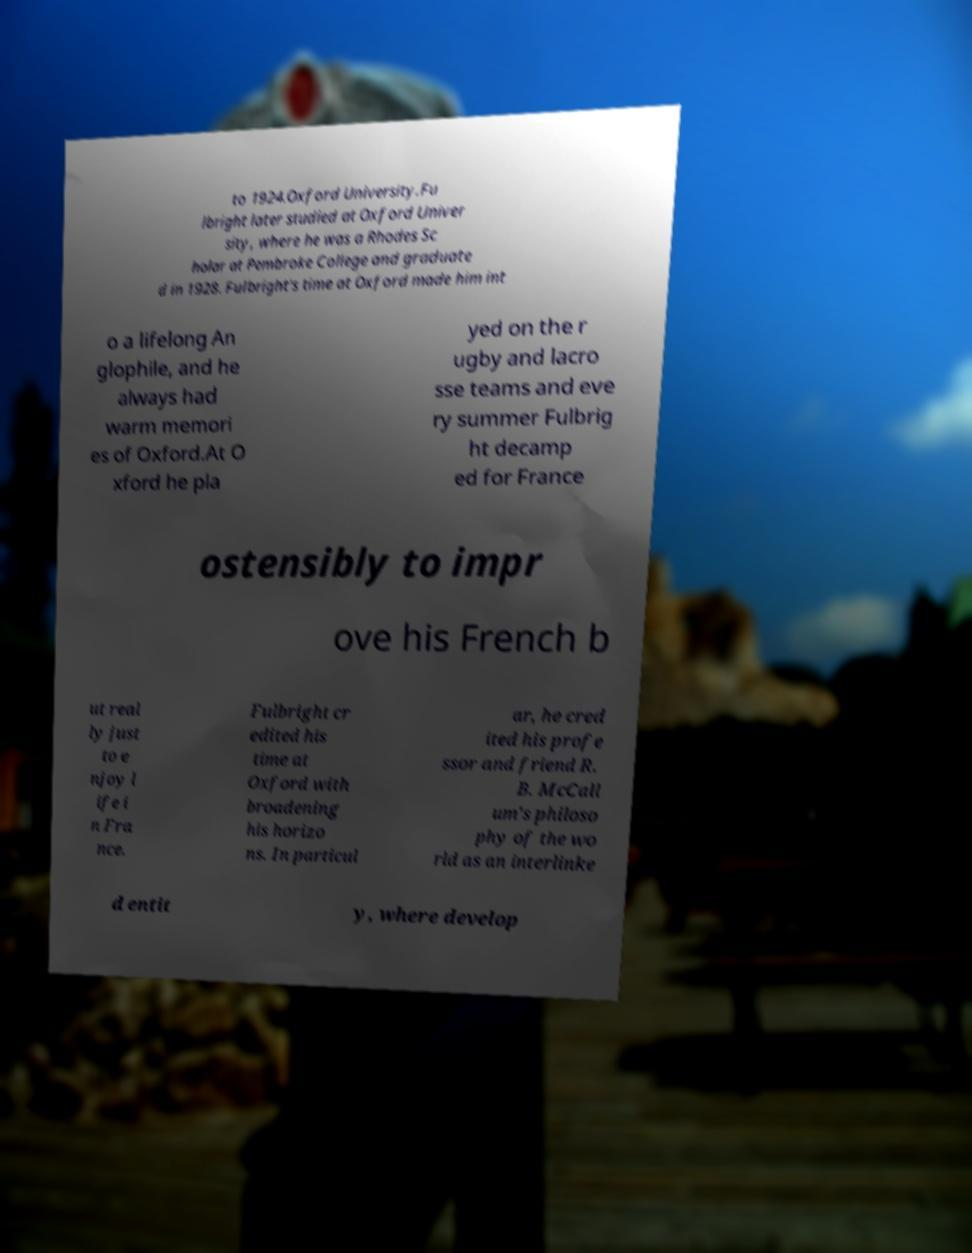Can you accurately transcribe the text from the provided image for me? to 1924.Oxford University.Fu lbright later studied at Oxford Univer sity, where he was a Rhodes Sc holar at Pembroke College and graduate d in 1928. Fulbright's time at Oxford made him int o a lifelong An glophile, and he always had warm memori es of Oxford.At O xford he pla yed on the r ugby and lacro sse teams and eve ry summer Fulbrig ht decamp ed for France ostensibly to impr ove his French b ut real ly just to e njoy l ife i n Fra nce. Fulbright cr edited his time at Oxford with broadening his horizo ns. In particul ar, he cred ited his profe ssor and friend R. B. McCall um's philoso phy of the wo rld as an interlinke d entit y, where develop 